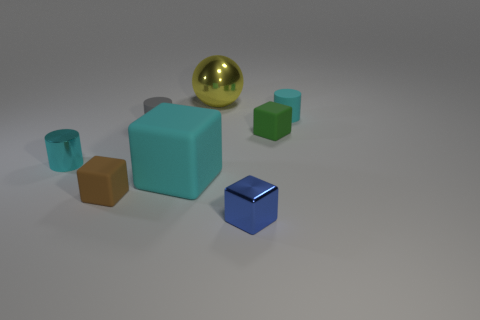Is the tiny metallic cylinder the same color as the metal block?
Provide a succinct answer. No. There is a small matte thing that is to the left of the blue shiny object and behind the brown block; what color is it?
Ensure brevity in your answer.  Gray. Do the cyan cylinder on the left side of the gray rubber thing and the big cyan cube have the same size?
Provide a succinct answer. No. Is there anything else that is the same shape as the small gray rubber thing?
Your answer should be very brief. Yes. Is the material of the green object the same as the cube that is on the left side of the large block?
Offer a very short reply. Yes. How many gray things are either big blocks or tiny things?
Provide a succinct answer. 1. Is there a yellow matte thing?
Give a very brief answer. No. Are there any big cyan things behind the cyan rubber object behind the small cyan object that is to the left of the tiny gray cylinder?
Your response must be concise. No. There is a small cyan matte object; does it have the same shape as the cyan object that is to the left of the small brown thing?
Your answer should be very brief. Yes. There is a tiny matte cylinder on the right side of the big yellow metal sphere behind the tiny matte cube that is on the right side of the big yellow metal object; what color is it?
Your response must be concise. Cyan. 